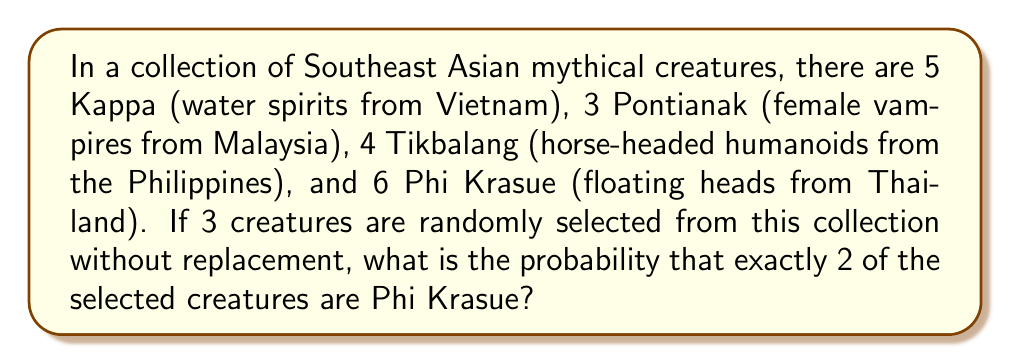Provide a solution to this math problem. Let's approach this step-by-step:

1. First, we need to calculate the total number of creatures:
   $5 + 3 + 4 + 6 = 18$ total creatures

2. We want to select 3 creatures in total, with exactly 2 being Phi Krasue. This means we need to select 2 Phi Krasue and 1 non-Phi Krasue.

3. To calculate this probability, we'll use the combination formula and multiply probabilities:

   $P(\text{2 Phi Krasue and 1 non-Phi Krasue}) = \frac{\binom{6}{2} \cdot \binom{12}{1}}{\binom{18}{3}}$

4. Let's calculate each part:
   - $\binom{6}{2}$ (ways to choose 2 Phi Krasue out of 6): $\frac{6!}{2!(6-2)!} = \frac{6 \cdot 5}{2 \cdot 1} = 15$
   - $\binom{12}{1}$ (ways to choose 1 non-Phi Krasue out of 12): $\frac{12!}{1!(12-1)!} = 12$
   - $\binom{18}{3}$ (total ways to choose 3 out of 18): $\frac{18!}{3!(18-3)!} = \frac{18 \cdot 17 \cdot 16}{3 \cdot 2 \cdot 1} = 816$

5. Now, let's put it all together:

   $P(\text{2 Phi Krasue and 1 non-Phi Krasue}) = \frac{15 \cdot 12}{816} = \frac{180}{816} = \frac{45}{204} \approx 0.2206$
Answer: $\frac{45}{204}$ 